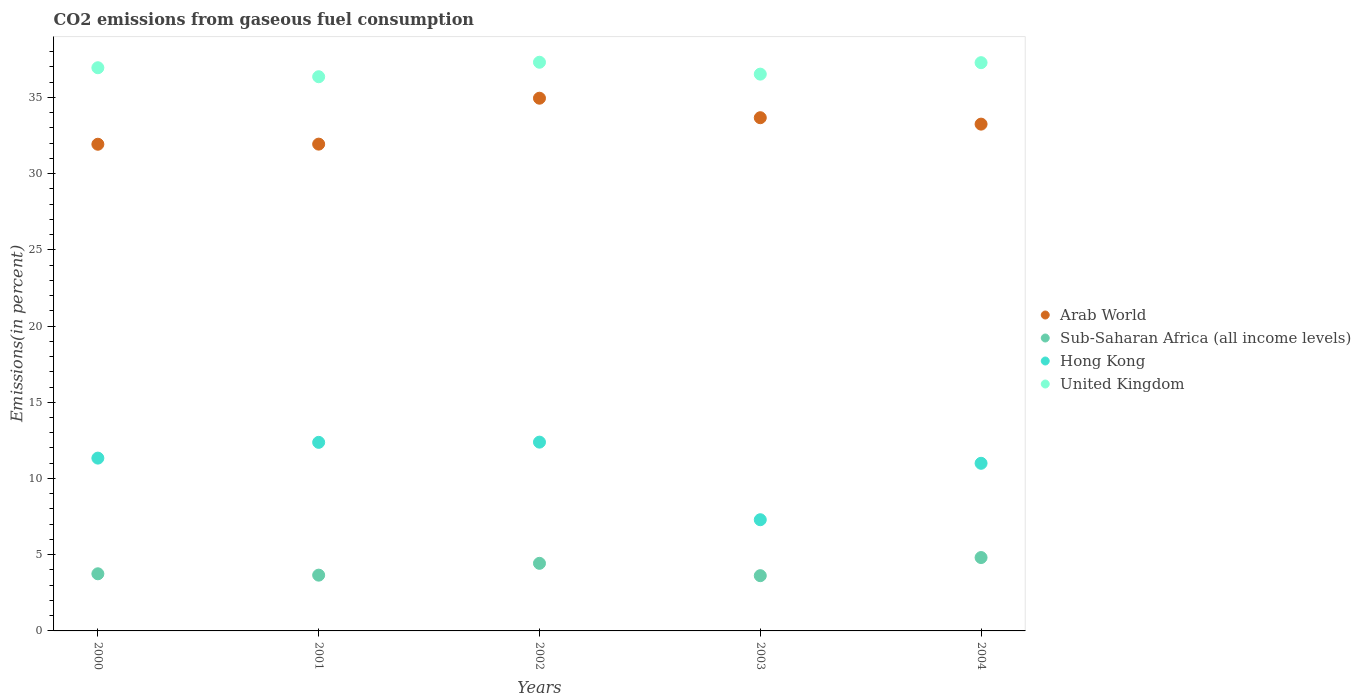How many different coloured dotlines are there?
Your answer should be very brief. 4. Is the number of dotlines equal to the number of legend labels?
Provide a succinct answer. Yes. What is the total CO2 emitted in Hong Kong in 2000?
Keep it short and to the point. 11.34. Across all years, what is the maximum total CO2 emitted in Arab World?
Provide a succinct answer. 34.95. Across all years, what is the minimum total CO2 emitted in Hong Kong?
Offer a very short reply. 7.29. In which year was the total CO2 emitted in United Kingdom maximum?
Ensure brevity in your answer.  2002. What is the total total CO2 emitted in Hong Kong in the graph?
Offer a very short reply. 54.38. What is the difference between the total CO2 emitted in United Kingdom in 2000 and that in 2003?
Give a very brief answer. 0.42. What is the difference between the total CO2 emitted in United Kingdom in 2002 and the total CO2 emitted in Sub-Saharan Africa (all income levels) in 2001?
Give a very brief answer. 33.65. What is the average total CO2 emitted in United Kingdom per year?
Ensure brevity in your answer.  36.88. In the year 2003, what is the difference between the total CO2 emitted in Arab World and total CO2 emitted in United Kingdom?
Keep it short and to the point. -2.86. In how many years, is the total CO2 emitted in Hong Kong greater than 23 %?
Your response must be concise. 0. What is the ratio of the total CO2 emitted in Sub-Saharan Africa (all income levels) in 2000 to that in 2001?
Provide a short and direct response. 1.02. What is the difference between the highest and the second highest total CO2 emitted in Arab World?
Offer a terse response. 1.28. What is the difference between the highest and the lowest total CO2 emitted in Arab World?
Offer a terse response. 3.02. In how many years, is the total CO2 emitted in Hong Kong greater than the average total CO2 emitted in Hong Kong taken over all years?
Ensure brevity in your answer.  4. Is the sum of the total CO2 emitted in Sub-Saharan Africa (all income levels) in 2003 and 2004 greater than the maximum total CO2 emitted in Hong Kong across all years?
Provide a short and direct response. No. Is it the case that in every year, the sum of the total CO2 emitted in Arab World and total CO2 emitted in Hong Kong  is greater than the total CO2 emitted in Sub-Saharan Africa (all income levels)?
Offer a very short reply. Yes. Does the total CO2 emitted in United Kingdom monotonically increase over the years?
Your answer should be compact. No. Is the total CO2 emitted in Hong Kong strictly greater than the total CO2 emitted in Arab World over the years?
Make the answer very short. No. Are the values on the major ticks of Y-axis written in scientific E-notation?
Ensure brevity in your answer.  No. How many legend labels are there?
Make the answer very short. 4. What is the title of the graph?
Make the answer very short. CO2 emissions from gaseous fuel consumption. What is the label or title of the Y-axis?
Provide a short and direct response. Emissions(in percent). What is the Emissions(in percent) of Arab World in 2000?
Provide a short and direct response. 31.93. What is the Emissions(in percent) in Sub-Saharan Africa (all income levels) in 2000?
Your answer should be very brief. 3.75. What is the Emissions(in percent) of Hong Kong in 2000?
Provide a succinct answer. 11.34. What is the Emissions(in percent) of United Kingdom in 2000?
Offer a very short reply. 36.95. What is the Emissions(in percent) of Arab World in 2001?
Keep it short and to the point. 31.93. What is the Emissions(in percent) in Sub-Saharan Africa (all income levels) in 2001?
Provide a short and direct response. 3.66. What is the Emissions(in percent) in Hong Kong in 2001?
Offer a terse response. 12.37. What is the Emissions(in percent) of United Kingdom in 2001?
Offer a terse response. 36.36. What is the Emissions(in percent) in Arab World in 2002?
Offer a very short reply. 34.95. What is the Emissions(in percent) of Sub-Saharan Africa (all income levels) in 2002?
Provide a succinct answer. 4.43. What is the Emissions(in percent) of Hong Kong in 2002?
Ensure brevity in your answer.  12.38. What is the Emissions(in percent) in United Kingdom in 2002?
Provide a short and direct response. 37.31. What is the Emissions(in percent) of Arab World in 2003?
Give a very brief answer. 33.67. What is the Emissions(in percent) in Sub-Saharan Africa (all income levels) in 2003?
Offer a very short reply. 3.62. What is the Emissions(in percent) of Hong Kong in 2003?
Your answer should be compact. 7.29. What is the Emissions(in percent) in United Kingdom in 2003?
Provide a short and direct response. 36.53. What is the Emissions(in percent) in Arab World in 2004?
Provide a short and direct response. 33.25. What is the Emissions(in percent) of Sub-Saharan Africa (all income levels) in 2004?
Make the answer very short. 4.81. What is the Emissions(in percent) in Hong Kong in 2004?
Your response must be concise. 11. What is the Emissions(in percent) of United Kingdom in 2004?
Your answer should be very brief. 37.28. Across all years, what is the maximum Emissions(in percent) in Arab World?
Provide a succinct answer. 34.95. Across all years, what is the maximum Emissions(in percent) of Sub-Saharan Africa (all income levels)?
Your answer should be very brief. 4.81. Across all years, what is the maximum Emissions(in percent) of Hong Kong?
Keep it short and to the point. 12.38. Across all years, what is the maximum Emissions(in percent) of United Kingdom?
Offer a terse response. 37.31. Across all years, what is the minimum Emissions(in percent) of Arab World?
Provide a short and direct response. 31.93. Across all years, what is the minimum Emissions(in percent) of Sub-Saharan Africa (all income levels)?
Give a very brief answer. 3.62. Across all years, what is the minimum Emissions(in percent) of Hong Kong?
Provide a short and direct response. 7.29. Across all years, what is the minimum Emissions(in percent) in United Kingdom?
Provide a succinct answer. 36.36. What is the total Emissions(in percent) in Arab World in the graph?
Your answer should be very brief. 165.72. What is the total Emissions(in percent) of Sub-Saharan Africa (all income levels) in the graph?
Ensure brevity in your answer.  20.28. What is the total Emissions(in percent) in Hong Kong in the graph?
Your response must be concise. 54.38. What is the total Emissions(in percent) in United Kingdom in the graph?
Provide a short and direct response. 184.41. What is the difference between the Emissions(in percent) in Arab World in 2000 and that in 2001?
Provide a short and direct response. -0.01. What is the difference between the Emissions(in percent) in Sub-Saharan Africa (all income levels) in 2000 and that in 2001?
Keep it short and to the point. 0.09. What is the difference between the Emissions(in percent) in Hong Kong in 2000 and that in 2001?
Keep it short and to the point. -1.03. What is the difference between the Emissions(in percent) of United Kingdom in 2000 and that in 2001?
Give a very brief answer. 0.59. What is the difference between the Emissions(in percent) of Arab World in 2000 and that in 2002?
Offer a very short reply. -3.02. What is the difference between the Emissions(in percent) of Sub-Saharan Africa (all income levels) in 2000 and that in 2002?
Provide a succinct answer. -0.69. What is the difference between the Emissions(in percent) in Hong Kong in 2000 and that in 2002?
Ensure brevity in your answer.  -1.05. What is the difference between the Emissions(in percent) of United Kingdom in 2000 and that in 2002?
Your response must be concise. -0.36. What is the difference between the Emissions(in percent) in Arab World in 2000 and that in 2003?
Provide a short and direct response. -1.74. What is the difference between the Emissions(in percent) in Sub-Saharan Africa (all income levels) in 2000 and that in 2003?
Make the answer very short. 0.12. What is the difference between the Emissions(in percent) of Hong Kong in 2000 and that in 2003?
Ensure brevity in your answer.  4.04. What is the difference between the Emissions(in percent) in United Kingdom in 2000 and that in 2003?
Give a very brief answer. 0.42. What is the difference between the Emissions(in percent) in Arab World in 2000 and that in 2004?
Offer a terse response. -1.32. What is the difference between the Emissions(in percent) of Sub-Saharan Africa (all income levels) in 2000 and that in 2004?
Your answer should be compact. -1.07. What is the difference between the Emissions(in percent) of Hong Kong in 2000 and that in 2004?
Your response must be concise. 0.34. What is the difference between the Emissions(in percent) in United Kingdom in 2000 and that in 2004?
Provide a succinct answer. -0.33. What is the difference between the Emissions(in percent) of Arab World in 2001 and that in 2002?
Make the answer very short. -3.01. What is the difference between the Emissions(in percent) of Sub-Saharan Africa (all income levels) in 2001 and that in 2002?
Provide a succinct answer. -0.78. What is the difference between the Emissions(in percent) in Hong Kong in 2001 and that in 2002?
Provide a succinct answer. -0.01. What is the difference between the Emissions(in percent) in United Kingdom in 2001 and that in 2002?
Give a very brief answer. -0.95. What is the difference between the Emissions(in percent) in Arab World in 2001 and that in 2003?
Your answer should be compact. -1.73. What is the difference between the Emissions(in percent) of Sub-Saharan Africa (all income levels) in 2001 and that in 2003?
Give a very brief answer. 0.03. What is the difference between the Emissions(in percent) of Hong Kong in 2001 and that in 2003?
Ensure brevity in your answer.  5.08. What is the difference between the Emissions(in percent) of United Kingdom in 2001 and that in 2003?
Your response must be concise. -0.17. What is the difference between the Emissions(in percent) in Arab World in 2001 and that in 2004?
Make the answer very short. -1.31. What is the difference between the Emissions(in percent) in Sub-Saharan Africa (all income levels) in 2001 and that in 2004?
Your answer should be compact. -1.15. What is the difference between the Emissions(in percent) in Hong Kong in 2001 and that in 2004?
Provide a short and direct response. 1.37. What is the difference between the Emissions(in percent) in United Kingdom in 2001 and that in 2004?
Your answer should be very brief. -0.92. What is the difference between the Emissions(in percent) of Arab World in 2002 and that in 2003?
Offer a very short reply. 1.28. What is the difference between the Emissions(in percent) of Sub-Saharan Africa (all income levels) in 2002 and that in 2003?
Offer a very short reply. 0.81. What is the difference between the Emissions(in percent) in Hong Kong in 2002 and that in 2003?
Ensure brevity in your answer.  5.09. What is the difference between the Emissions(in percent) in United Kingdom in 2002 and that in 2003?
Keep it short and to the point. 0.78. What is the difference between the Emissions(in percent) in Arab World in 2002 and that in 2004?
Your answer should be very brief. 1.7. What is the difference between the Emissions(in percent) in Sub-Saharan Africa (all income levels) in 2002 and that in 2004?
Your answer should be very brief. -0.38. What is the difference between the Emissions(in percent) in Hong Kong in 2002 and that in 2004?
Your answer should be very brief. 1.39. What is the difference between the Emissions(in percent) of United Kingdom in 2002 and that in 2004?
Keep it short and to the point. 0.03. What is the difference between the Emissions(in percent) of Arab World in 2003 and that in 2004?
Your answer should be compact. 0.42. What is the difference between the Emissions(in percent) in Sub-Saharan Africa (all income levels) in 2003 and that in 2004?
Your response must be concise. -1.19. What is the difference between the Emissions(in percent) of Hong Kong in 2003 and that in 2004?
Provide a short and direct response. -3.7. What is the difference between the Emissions(in percent) in United Kingdom in 2003 and that in 2004?
Ensure brevity in your answer.  -0.75. What is the difference between the Emissions(in percent) of Arab World in 2000 and the Emissions(in percent) of Sub-Saharan Africa (all income levels) in 2001?
Your response must be concise. 28.27. What is the difference between the Emissions(in percent) of Arab World in 2000 and the Emissions(in percent) of Hong Kong in 2001?
Offer a very short reply. 19.56. What is the difference between the Emissions(in percent) of Arab World in 2000 and the Emissions(in percent) of United Kingdom in 2001?
Provide a succinct answer. -4.43. What is the difference between the Emissions(in percent) of Sub-Saharan Africa (all income levels) in 2000 and the Emissions(in percent) of Hong Kong in 2001?
Offer a terse response. -8.62. What is the difference between the Emissions(in percent) of Sub-Saharan Africa (all income levels) in 2000 and the Emissions(in percent) of United Kingdom in 2001?
Offer a very short reply. -32.61. What is the difference between the Emissions(in percent) of Hong Kong in 2000 and the Emissions(in percent) of United Kingdom in 2001?
Make the answer very short. -25.02. What is the difference between the Emissions(in percent) of Arab World in 2000 and the Emissions(in percent) of Sub-Saharan Africa (all income levels) in 2002?
Offer a terse response. 27.49. What is the difference between the Emissions(in percent) of Arab World in 2000 and the Emissions(in percent) of Hong Kong in 2002?
Your answer should be very brief. 19.54. What is the difference between the Emissions(in percent) in Arab World in 2000 and the Emissions(in percent) in United Kingdom in 2002?
Offer a terse response. -5.38. What is the difference between the Emissions(in percent) of Sub-Saharan Africa (all income levels) in 2000 and the Emissions(in percent) of Hong Kong in 2002?
Keep it short and to the point. -8.64. What is the difference between the Emissions(in percent) of Sub-Saharan Africa (all income levels) in 2000 and the Emissions(in percent) of United Kingdom in 2002?
Your answer should be very brief. -33.56. What is the difference between the Emissions(in percent) of Hong Kong in 2000 and the Emissions(in percent) of United Kingdom in 2002?
Your answer should be compact. -25.97. What is the difference between the Emissions(in percent) of Arab World in 2000 and the Emissions(in percent) of Sub-Saharan Africa (all income levels) in 2003?
Make the answer very short. 28.3. What is the difference between the Emissions(in percent) of Arab World in 2000 and the Emissions(in percent) of Hong Kong in 2003?
Your answer should be compact. 24.63. What is the difference between the Emissions(in percent) of Arab World in 2000 and the Emissions(in percent) of United Kingdom in 2003?
Provide a short and direct response. -4.6. What is the difference between the Emissions(in percent) of Sub-Saharan Africa (all income levels) in 2000 and the Emissions(in percent) of Hong Kong in 2003?
Provide a succinct answer. -3.55. What is the difference between the Emissions(in percent) of Sub-Saharan Africa (all income levels) in 2000 and the Emissions(in percent) of United Kingdom in 2003?
Give a very brief answer. -32.78. What is the difference between the Emissions(in percent) of Hong Kong in 2000 and the Emissions(in percent) of United Kingdom in 2003?
Your answer should be very brief. -25.19. What is the difference between the Emissions(in percent) of Arab World in 2000 and the Emissions(in percent) of Sub-Saharan Africa (all income levels) in 2004?
Make the answer very short. 27.11. What is the difference between the Emissions(in percent) of Arab World in 2000 and the Emissions(in percent) of Hong Kong in 2004?
Provide a succinct answer. 20.93. What is the difference between the Emissions(in percent) in Arab World in 2000 and the Emissions(in percent) in United Kingdom in 2004?
Offer a terse response. -5.35. What is the difference between the Emissions(in percent) in Sub-Saharan Africa (all income levels) in 2000 and the Emissions(in percent) in Hong Kong in 2004?
Your response must be concise. -7.25. What is the difference between the Emissions(in percent) of Sub-Saharan Africa (all income levels) in 2000 and the Emissions(in percent) of United Kingdom in 2004?
Your answer should be compact. -33.53. What is the difference between the Emissions(in percent) of Hong Kong in 2000 and the Emissions(in percent) of United Kingdom in 2004?
Give a very brief answer. -25.94. What is the difference between the Emissions(in percent) in Arab World in 2001 and the Emissions(in percent) in Sub-Saharan Africa (all income levels) in 2002?
Keep it short and to the point. 27.5. What is the difference between the Emissions(in percent) in Arab World in 2001 and the Emissions(in percent) in Hong Kong in 2002?
Give a very brief answer. 19.55. What is the difference between the Emissions(in percent) of Arab World in 2001 and the Emissions(in percent) of United Kingdom in 2002?
Your answer should be compact. -5.37. What is the difference between the Emissions(in percent) of Sub-Saharan Africa (all income levels) in 2001 and the Emissions(in percent) of Hong Kong in 2002?
Give a very brief answer. -8.73. What is the difference between the Emissions(in percent) of Sub-Saharan Africa (all income levels) in 2001 and the Emissions(in percent) of United Kingdom in 2002?
Give a very brief answer. -33.65. What is the difference between the Emissions(in percent) of Hong Kong in 2001 and the Emissions(in percent) of United Kingdom in 2002?
Offer a terse response. -24.94. What is the difference between the Emissions(in percent) of Arab World in 2001 and the Emissions(in percent) of Sub-Saharan Africa (all income levels) in 2003?
Your answer should be very brief. 28.31. What is the difference between the Emissions(in percent) in Arab World in 2001 and the Emissions(in percent) in Hong Kong in 2003?
Provide a short and direct response. 24.64. What is the difference between the Emissions(in percent) in Arab World in 2001 and the Emissions(in percent) in United Kingdom in 2003?
Make the answer very short. -4.59. What is the difference between the Emissions(in percent) of Sub-Saharan Africa (all income levels) in 2001 and the Emissions(in percent) of Hong Kong in 2003?
Ensure brevity in your answer.  -3.64. What is the difference between the Emissions(in percent) in Sub-Saharan Africa (all income levels) in 2001 and the Emissions(in percent) in United Kingdom in 2003?
Ensure brevity in your answer.  -32.87. What is the difference between the Emissions(in percent) of Hong Kong in 2001 and the Emissions(in percent) of United Kingdom in 2003?
Provide a succinct answer. -24.16. What is the difference between the Emissions(in percent) of Arab World in 2001 and the Emissions(in percent) of Sub-Saharan Africa (all income levels) in 2004?
Make the answer very short. 27.12. What is the difference between the Emissions(in percent) of Arab World in 2001 and the Emissions(in percent) of Hong Kong in 2004?
Ensure brevity in your answer.  20.94. What is the difference between the Emissions(in percent) of Arab World in 2001 and the Emissions(in percent) of United Kingdom in 2004?
Your response must be concise. -5.34. What is the difference between the Emissions(in percent) in Sub-Saharan Africa (all income levels) in 2001 and the Emissions(in percent) in Hong Kong in 2004?
Your answer should be compact. -7.34. What is the difference between the Emissions(in percent) in Sub-Saharan Africa (all income levels) in 2001 and the Emissions(in percent) in United Kingdom in 2004?
Your answer should be very brief. -33.62. What is the difference between the Emissions(in percent) in Hong Kong in 2001 and the Emissions(in percent) in United Kingdom in 2004?
Give a very brief answer. -24.91. What is the difference between the Emissions(in percent) in Arab World in 2002 and the Emissions(in percent) in Sub-Saharan Africa (all income levels) in 2003?
Offer a terse response. 31.32. What is the difference between the Emissions(in percent) in Arab World in 2002 and the Emissions(in percent) in Hong Kong in 2003?
Your response must be concise. 27.65. What is the difference between the Emissions(in percent) in Arab World in 2002 and the Emissions(in percent) in United Kingdom in 2003?
Give a very brief answer. -1.58. What is the difference between the Emissions(in percent) in Sub-Saharan Africa (all income levels) in 2002 and the Emissions(in percent) in Hong Kong in 2003?
Ensure brevity in your answer.  -2.86. What is the difference between the Emissions(in percent) in Sub-Saharan Africa (all income levels) in 2002 and the Emissions(in percent) in United Kingdom in 2003?
Your response must be concise. -32.09. What is the difference between the Emissions(in percent) in Hong Kong in 2002 and the Emissions(in percent) in United Kingdom in 2003?
Your response must be concise. -24.14. What is the difference between the Emissions(in percent) of Arab World in 2002 and the Emissions(in percent) of Sub-Saharan Africa (all income levels) in 2004?
Keep it short and to the point. 30.13. What is the difference between the Emissions(in percent) in Arab World in 2002 and the Emissions(in percent) in Hong Kong in 2004?
Your answer should be very brief. 23.95. What is the difference between the Emissions(in percent) in Arab World in 2002 and the Emissions(in percent) in United Kingdom in 2004?
Make the answer very short. -2.33. What is the difference between the Emissions(in percent) in Sub-Saharan Africa (all income levels) in 2002 and the Emissions(in percent) in Hong Kong in 2004?
Provide a succinct answer. -6.56. What is the difference between the Emissions(in percent) in Sub-Saharan Africa (all income levels) in 2002 and the Emissions(in percent) in United Kingdom in 2004?
Give a very brief answer. -32.84. What is the difference between the Emissions(in percent) in Hong Kong in 2002 and the Emissions(in percent) in United Kingdom in 2004?
Keep it short and to the point. -24.89. What is the difference between the Emissions(in percent) in Arab World in 2003 and the Emissions(in percent) in Sub-Saharan Africa (all income levels) in 2004?
Your response must be concise. 28.85. What is the difference between the Emissions(in percent) in Arab World in 2003 and the Emissions(in percent) in Hong Kong in 2004?
Offer a very short reply. 22.67. What is the difference between the Emissions(in percent) of Arab World in 2003 and the Emissions(in percent) of United Kingdom in 2004?
Provide a short and direct response. -3.61. What is the difference between the Emissions(in percent) in Sub-Saharan Africa (all income levels) in 2003 and the Emissions(in percent) in Hong Kong in 2004?
Provide a short and direct response. -7.37. What is the difference between the Emissions(in percent) in Sub-Saharan Africa (all income levels) in 2003 and the Emissions(in percent) in United Kingdom in 2004?
Keep it short and to the point. -33.65. What is the difference between the Emissions(in percent) of Hong Kong in 2003 and the Emissions(in percent) of United Kingdom in 2004?
Give a very brief answer. -29.98. What is the average Emissions(in percent) in Arab World per year?
Your response must be concise. 33.14. What is the average Emissions(in percent) in Sub-Saharan Africa (all income levels) per year?
Provide a succinct answer. 4.06. What is the average Emissions(in percent) of Hong Kong per year?
Your answer should be compact. 10.88. What is the average Emissions(in percent) of United Kingdom per year?
Provide a succinct answer. 36.88. In the year 2000, what is the difference between the Emissions(in percent) in Arab World and Emissions(in percent) in Sub-Saharan Africa (all income levels)?
Your answer should be very brief. 28.18. In the year 2000, what is the difference between the Emissions(in percent) in Arab World and Emissions(in percent) in Hong Kong?
Ensure brevity in your answer.  20.59. In the year 2000, what is the difference between the Emissions(in percent) in Arab World and Emissions(in percent) in United Kingdom?
Offer a terse response. -5.02. In the year 2000, what is the difference between the Emissions(in percent) of Sub-Saharan Africa (all income levels) and Emissions(in percent) of Hong Kong?
Offer a very short reply. -7.59. In the year 2000, what is the difference between the Emissions(in percent) in Sub-Saharan Africa (all income levels) and Emissions(in percent) in United Kingdom?
Offer a very short reply. -33.2. In the year 2000, what is the difference between the Emissions(in percent) in Hong Kong and Emissions(in percent) in United Kingdom?
Offer a very short reply. -25.61. In the year 2001, what is the difference between the Emissions(in percent) in Arab World and Emissions(in percent) in Sub-Saharan Africa (all income levels)?
Your response must be concise. 28.28. In the year 2001, what is the difference between the Emissions(in percent) in Arab World and Emissions(in percent) in Hong Kong?
Your response must be concise. 19.56. In the year 2001, what is the difference between the Emissions(in percent) in Arab World and Emissions(in percent) in United Kingdom?
Make the answer very short. -4.42. In the year 2001, what is the difference between the Emissions(in percent) in Sub-Saharan Africa (all income levels) and Emissions(in percent) in Hong Kong?
Provide a succinct answer. -8.71. In the year 2001, what is the difference between the Emissions(in percent) of Sub-Saharan Africa (all income levels) and Emissions(in percent) of United Kingdom?
Provide a short and direct response. -32.7. In the year 2001, what is the difference between the Emissions(in percent) in Hong Kong and Emissions(in percent) in United Kingdom?
Make the answer very short. -23.98. In the year 2002, what is the difference between the Emissions(in percent) of Arab World and Emissions(in percent) of Sub-Saharan Africa (all income levels)?
Give a very brief answer. 30.51. In the year 2002, what is the difference between the Emissions(in percent) in Arab World and Emissions(in percent) in Hong Kong?
Provide a succinct answer. 22.56. In the year 2002, what is the difference between the Emissions(in percent) of Arab World and Emissions(in percent) of United Kingdom?
Your response must be concise. -2.36. In the year 2002, what is the difference between the Emissions(in percent) in Sub-Saharan Africa (all income levels) and Emissions(in percent) in Hong Kong?
Keep it short and to the point. -7.95. In the year 2002, what is the difference between the Emissions(in percent) in Sub-Saharan Africa (all income levels) and Emissions(in percent) in United Kingdom?
Provide a short and direct response. -32.87. In the year 2002, what is the difference between the Emissions(in percent) of Hong Kong and Emissions(in percent) of United Kingdom?
Offer a very short reply. -24.92. In the year 2003, what is the difference between the Emissions(in percent) of Arab World and Emissions(in percent) of Sub-Saharan Africa (all income levels)?
Make the answer very short. 30.04. In the year 2003, what is the difference between the Emissions(in percent) of Arab World and Emissions(in percent) of Hong Kong?
Give a very brief answer. 26.37. In the year 2003, what is the difference between the Emissions(in percent) of Arab World and Emissions(in percent) of United Kingdom?
Give a very brief answer. -2.86. In the year 2003, what is the difference between the Emissions(in percent) in Sub-Saharan Africa (all income levels) and Emissions(in percent) in Hong Kong?
Your answer should be very brief. -3.67. In the year 2003, what is the difference between the Emissions(in percent) in Sub-Saharan Africa (all income levels) and Emissions(in percent) in United Kingdom?
Provide a short and direct response. -32.9. In the year 2003, what is the difference between the Emissions(in percent) in Hong Kong and Emissions(in percent) in United Kingdom?
Keep it short and to the point. -29.23. In the year 2004, what is the difference between the Emissions(in percent) of Arab World and Emissions(in percent) of Sub-Saharan Africa (all income levels)?
Keep it short and to the point. 28.43. In the year 2004, what is the difference between the Emissions(in percent) in Arab World and Emissions(in percent) in Hong Kong?
Provide a short and direct response. 22.25. In the year 2004, what is the difference between the Emissions(in percent) of Arab World and Emissions(in percent) of United Kingdom?
Offer a terse response. -4.03. In the year 2004, what is the difference between the Emissions(in percent) of Sub-Saharan Africa (all income levels) and Emissions(in percent) of Hong Kong?
Provide a short and direct response. -6.18. In the year 2004, what is the difference between the Emissions(in percent) in Sub-Saharan Africa (all income levels) and Emissions(in percent) in United Kingdom?
Provide a short and direct response. -32.46. In the year 2004, what is the difference between the Emissions(in percent) of Hong Kong and Emissions(in percent) of United Kingdom?
Provide a short and direct response. -26.28. What is the ratio of the Emissions(in percent) of Arab World in 2000 to that in 2001?
Ensure brevity in your answer.  1. What is the ratio of the Emissions(in percent) of Sub-Saharan Africa (all income levels) in 2000 to that in 2001?
Your answer should be very brief. 1.02. What is the ratio of the Emissions(in percent) in Hong Kong in 2000 to that in 2001?
Keep it short and to the point. 0.92. What is the ratio of the Emissions(in percent) in United Kingdom in 2000 to that in 2001?
Provide a short and direct response. 1.02. What is the ratio of the Emissions(in percent) of Arab World in 2000 to that in 2002?
Offer a very short reply. 0.91. What is the ratio of the Emissions(in percent) of Sub-Saharan Africa (all income levels) in 2000 to that in 2002?
Your response must be concise. 0.85. What is the ratio of the Emissions(in percent) in Hong Kong in 2000 to that in 2002?
Your response must be concise. 0.92. What is the ratio of the Emissions(in percent) of United Kingdom in 2000 to that in 2002?
Your answer should be compact. 0.99. What is the ratio of the Emissions(in percent) in Arab World in 2000 to that in 2003?
Give a very brief answer. 0.95. What is the ratio of the Emissions(in percent) in Sub-Saharan Africa (all income levels) in 2000 to that in 2003?
Keep it short and to the point. 1.03. What is the ratio of the Emissions(in percent) in Hong Kong in 2000 to that in 2003?
Your response must be concise. 1.55. What is the ratio of the Emissions(in percent) in United Kingdom in 2000 to that in 2003?
Make the answer very short. 1.01. What is the ratio of the Emissions(in percent) in Arab World in 2000 to that in 2004?
Offer a very short reply. 0.96. What is the ratio of the Emissions(in percent) of Sub-Saharan Africa (all income levels) in 2000 to that in 2004?
Keep it short and to the point. 0.78. What is the ratio of the Emissions(in percent) in Hong Kong in 2000 to that in 2004?
Offer a very short reply. 1.03. What is the ratio of the Emissions(in percent) in Arab World in 2001 to that in 2002?
Your answer should be compact. 0.91. What is the ratio of the Emissions(in percent) in Sub-Saharan Africa (all income levels) in 2001 to that in 2002?
Your answer should be very brief. 0.83. What is the ratio of the Emissions(in percent) of Hong Kong in 2001 to that in 2002?
Offer a very short reply. 1. What is the ratio of the Emissions(in percent) in United Kingdom in 2001 to that in 2002?
Your answer should be very brief. 0.97. What is the ratio of the Emissions(in percent) of Arab World in 2001 to that in 2003?
Your response must be concise. 0.95. What is the ratio of the Emissions(in percent) of Sub-Saharan Africa (all income levels) in 2001 to that in 2003?
Give a very brief answer. 1.01. What is the ratio of the Emissions(in percent) of Hong Kong in 2001 to that in 2003?
Give a very brief answer. 1.7. What is the ratio of the Emissions(in percent) of Arab World in 2001 to that in 2004?
Offer a very short reply. 0.96. What is the ratio of the Emissions(in percent) of Sub-Saharan Africa (all income levels) in 2001 to that in 2004?
Make the answer very short. 0.76. What is the ratio of the Emissions(in percent) of United Kingdom in 2001 to that in 2004?
Your answer should be very brief. 0.98. What is the ratio of the Emissions(in percent) in Arab World in 2002 to that in 2003?
Your answer should be compact. 1.04. What is the ratio of the Emissions(in percent) in Sub-Saharan Africa (all income levels) in 2002 to that in 2003?
Offer a very short reply. 1.22. What is the ratio of the Emissions(in percent) in Hong Kong in 2002 to that in 2003?
Offer a very short reply. 1.7. What is the ratio of the Emissions(in percent) in United Kingdom in 2002 to that in 2003?
Give a very brief answer. 1.02. What is the ratio of the Emissions(in percent) of Arab World in 2002 to that in 2004?
Give a very brief answer. 1.05. What is the ratio of the Emissions(in percent) of Sub-Saharan Africa (all income levels) in 2002 to that in 2004?
Keep it short and to the point. 0.92. What is the ratio of the Emissions(in percent) of Hong Kong in 2002 to that in 2004?
Provide a succinct answer. 1.13. What is the ratio of the Emissions(in percent) in United Kingdom in 2002 to that in 2004?
Offer a terse response. 1. What is the ratio of the Emissions(in percent) of Arab World in 2003 to that in 2004?
Provide a succinct answer. 1.01. What is the ratio of the Emissions(in percent) of Sub-Saharan Africa (all income levels) in 2003 to that in 2004?
Keep it short and to the point. 0.75. What is the ratio of the Emissions(in percent) in Hong Kong in 2003 to that in 2004?
Give a very brief answer. 0.66. What is the ratio of the Emissions(in percent) of United Kingdom in 2003 to that in 2004?
Provide a short and direct response. 0.98. What is the difference between the highest and the second highest Emissions(in percent) in Arab World?
Your answer should be very brief. 1.28. What is the difference between the highest and the second highest Emissions(in percent) of Sub-Saharan Africa (all income levels)?
Ensure brevity in your answer.  0.38. What is the difference between the highest and the second highest Emissions(in percent) in Hong Kong?
Provide a short and direct response. 0.01. What is the difference between the highest and the second highest Emissions(in percent) in United Kingdom?
Keep it short and to the point. 0.03. What is the difference between the highest and the lowest Emissions(in percent) in Arab World?
Provide a succinct answer. 3.02. What is the difference between the highest and the lowest Emissions(in percent) in Sub-Saharan Africa (all income levels)?
Your answer should be very brief. 1.19. What is the difference between the highest and the lowest Emissions(in percent) of Hong Kong?
Provide a succinct answer. 5.09. What is the difference between the highest and the lowest Emissions(in percent) in United Kingdom?
Offer a very short reply. 0.95. 